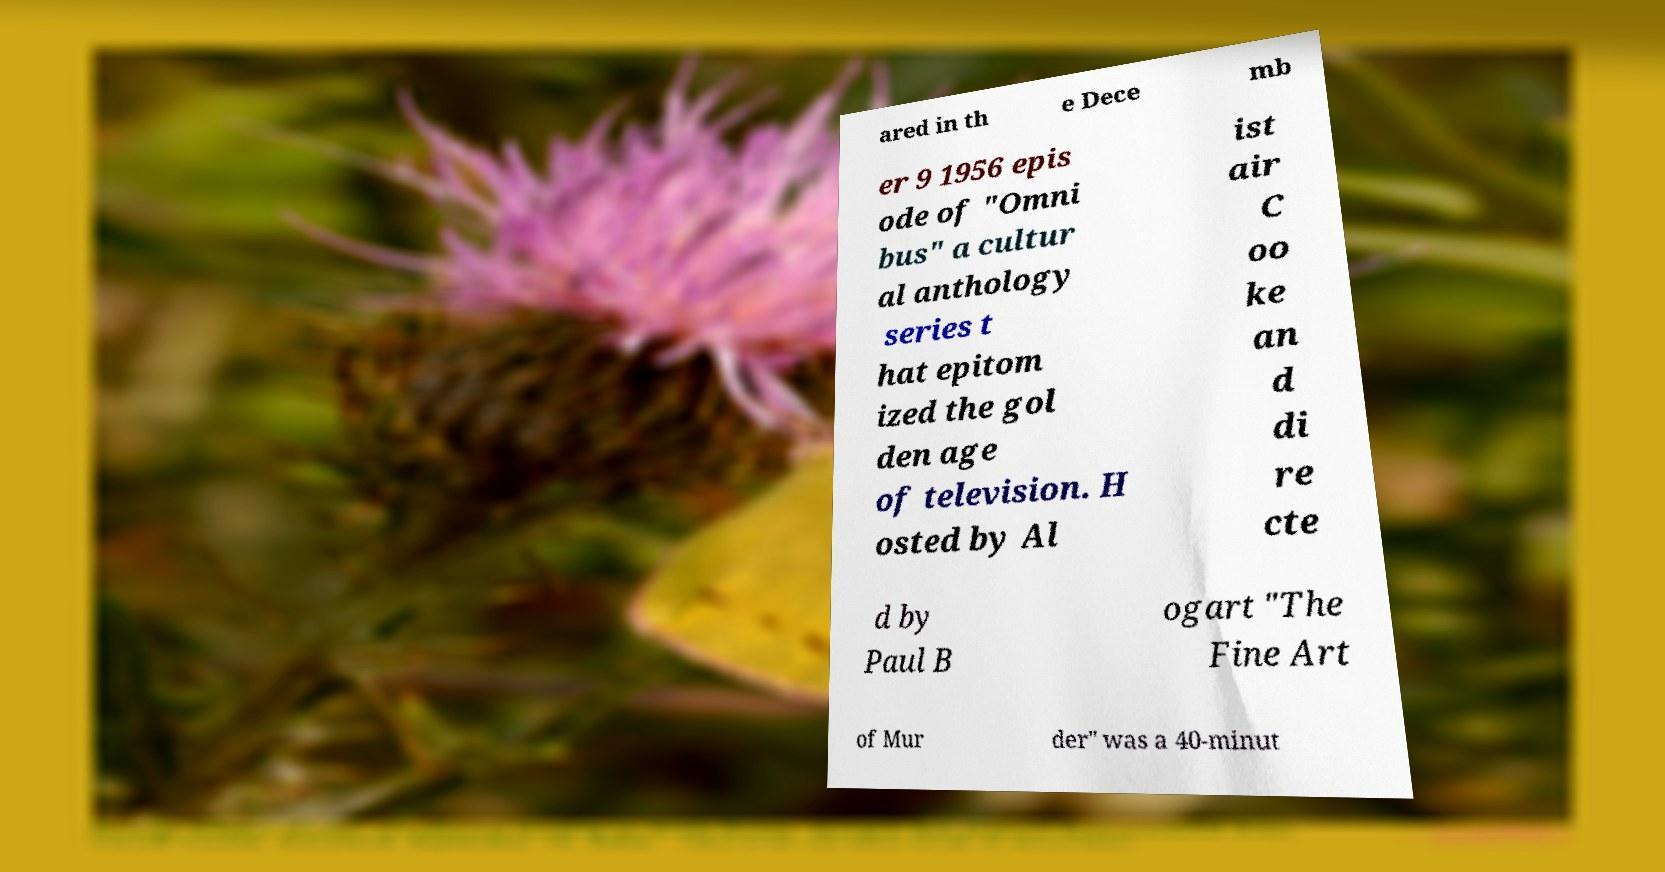Could you assist in decoding the text presented in this image and type it out clearly? ared in th e Dece mb er 9 1956 epis ode of "Omni bus" a cultur al anthology series t hat epitom ized the gol den age of television. H osted by Al ist air C oo ke an d di re cte d by Paul B ogart "The Fine Art of Mur der" was a 40-minut 